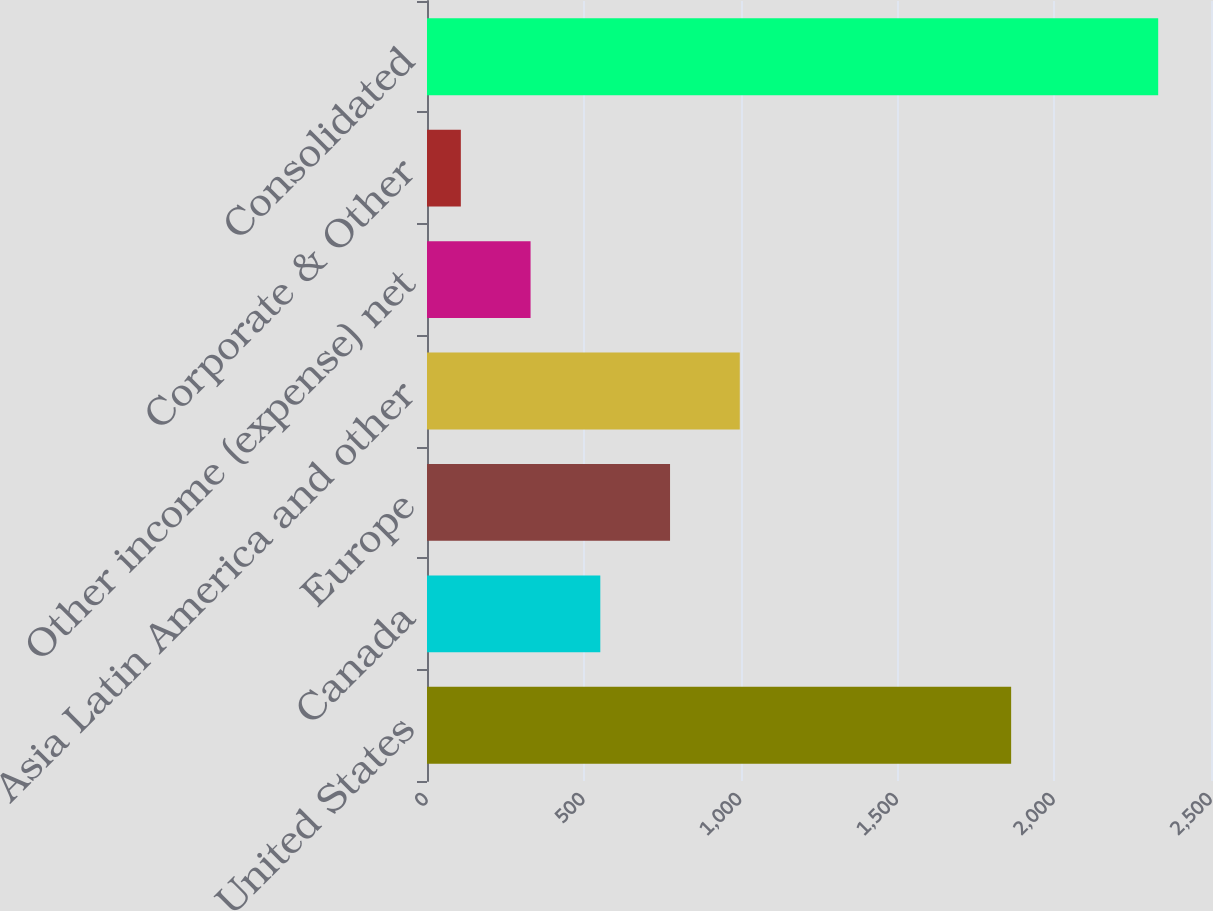<chart> <loc_0><loc_0><loc_500><loc_500><bar_chart><fcel>United States<fcel>Canada<fcel>Europe<fcel>Asia Latin America and other<fcel>Other income (expense) net<fcel>Corporate & Other<fcel>Consolidated<nl><fcel>1862.7<fcel>552.64<fcel>775.01<fcel>997.38<fcel>330.27<fcel>107.9<fcel>2331.6<nl></chart> 